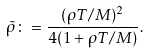<formula> <loc_0><loc_0><loc_500><loc_500>\tilde { \rho } \colon = \frac { ( \rho T / M ) ^ { 2 } } { 4 ( 1 + \rho T / M ) } .</formula> 